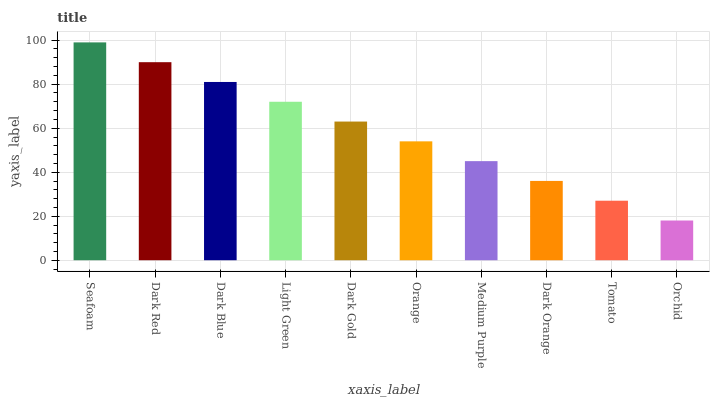Is Orchid the minimum?
Answer yes or no. Yes. Is Seafoam the maximum?
Answer yes or no. Yes. Is Dark Red the minimum?
Answer yes or no. No. Is Dark Red the maximum?
Answer yes or no. No. Is Seafoam greater than Dark Red?
Answer yes or no. Yes. Is Dark Red less than Seafoam?
Answer yes or no. Yes. Is Dark Red greater than Seafoam?
Answer yes or no. No. Is Seafoam less than Dark Red?
Answer yes or no. No. Is Dark Gold the high median?
Answer yes or no. Yes. Is Orange the low median?
Answer yes or no. Yes. Is Dark Orange the high median?
Answer yes or no. No. Is Dark Gold the low median?
Answer yes or no. No. 